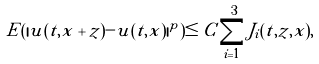Convert formula to latex. <formula><loc_0><loc_0><loc_500><loc_500>E ( | u ( t , x + z ) - u ( t , x ) | ^ { p } ) \leq C \sum _ { i = 1 } ^ { 3 } J _ { i } ( t , z , x ) ,</formula> 